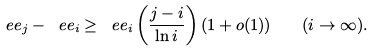Convert formula to latex. <formula><loc_0><loc_0><loc_500><loc_500>\ e e _ { j } - \ e e _ { i } \geq \ e e _ { i } \left ( \frac { j - i } { \ln i } \right ) ( 1 + o ( 1 ) ) \quad ( i \to \infty ) .</formula> 